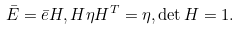<formula> <loc_0><loc_0><loc_500><loc_500>\bar { E } = \bar { e } H , H \eta H ^ { T } = \eta , \det H = 1 .</formula> 